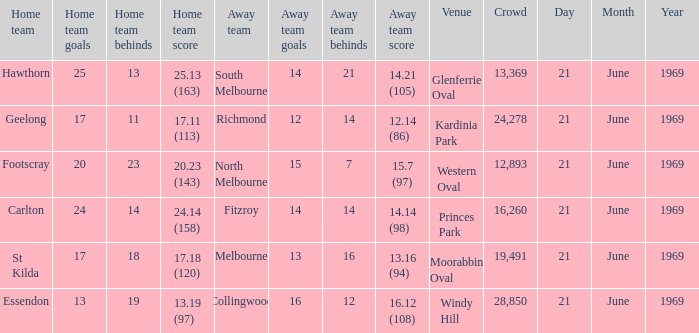What is Essendon's home team that has an away crowd size larger than 19,491? Collingwood. 